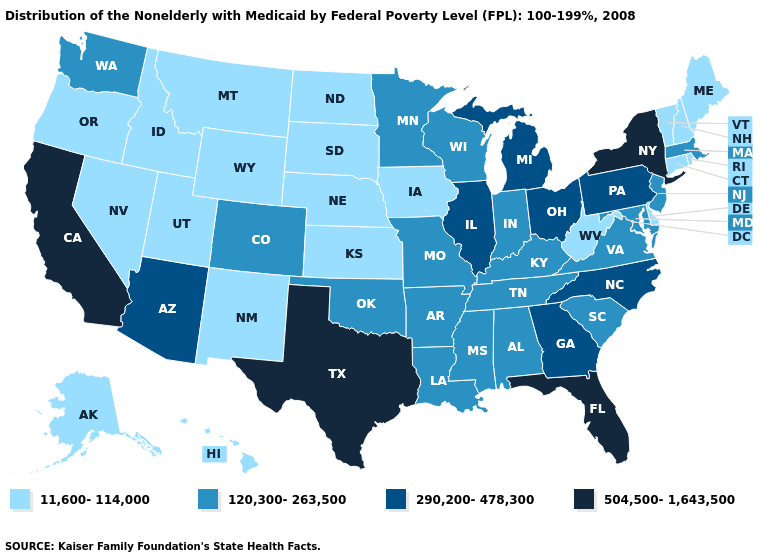Does Kentucky have the lowest value in the South?
Keep it brief. No. What is the lowest value in states that border Louisiana?
Concise answer only. 120,300-263,500. What is the highest value in states that border Washington?
Quick response, please. 11,600-114,000. What is the value of Virginia?
Answer briefly. 120,300-263,500. What is the lowest value in the USA?
Quick response, please. 11,600-114,000. Name the states that have a value in the range 120,300-263,500?
Short answer required. Alabama, Arkansas, Colorado, Indiana, Kentucky, Louisiana, Maryland, Massachusetts, Minnesota, Mississippi, Missouri, New Jersey, Oklahoma, South Carolina, Tennessee, Virginia, Washington, Wisconsin. Does Michigan have the highest value in the MidWest?
Give a very brief answer. Yes. Name the states that have a value in the range 290,200-478,300?
Keep it brief. Arizona, Georgia, Illinois, Michigan, North Carolina, Ohio, Pennsylvania. What is the value of California?
Give a very brief answer. 504,500-1,643,500. What is the value of Indiana?
Give a very brief answer. 120,300-263,500. Does Washington have the lowest value in the West?
Concise answer only. No. Which states have the lowest value in the West?
Keep it brief. Alaska, Hawaii, Idaho, Montana, Nevada, New Mexico, Oregon, Utah, Wyoming. Name the states that have a value in the range 11,600-114,000?
Short answer required. Alaska, Connecticut, Delaware, Hawaii, Idaho, Iowa, Kansas, Maine, Montana, Nebraska, Nevada, New Hampshire, New Mexico, North Dakota, Oregon, Rhode Island, South Dakota, Utah, Vermont, West Virginia, Wyoming. Among the states that border Massachusetts , which have the highest value?
Keep it brief. New York. 